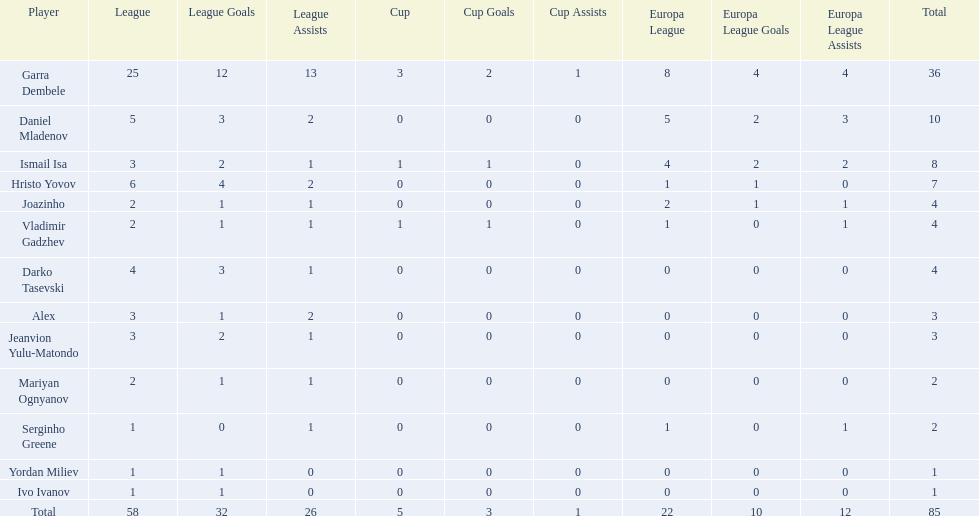What players did not score in all 3 competitions? Daniel Mladenov, Hristo Yovov, Joazinho, Darko Tasevski, Alex, Jeanvion Yulu-Matondo, Mariyan Ognyanov, Serginho Greene, Yordan Miliev, Ivo Ivanov. Which of those did not have total more then 5? Darko Tasevski, Alex, Jeanvion Yulu-Matondo, Mariyan Ognyanov, Serginho Greene, Yordan Miliev, Ivo Ivanov. Which ones scored more then 1 total? Darko Tasevski, Alex, Jeanvion Yulu-Matondo, Mariyan Ognyanov. Which of these player had the lease league points? Mariyan Ognyanov. 